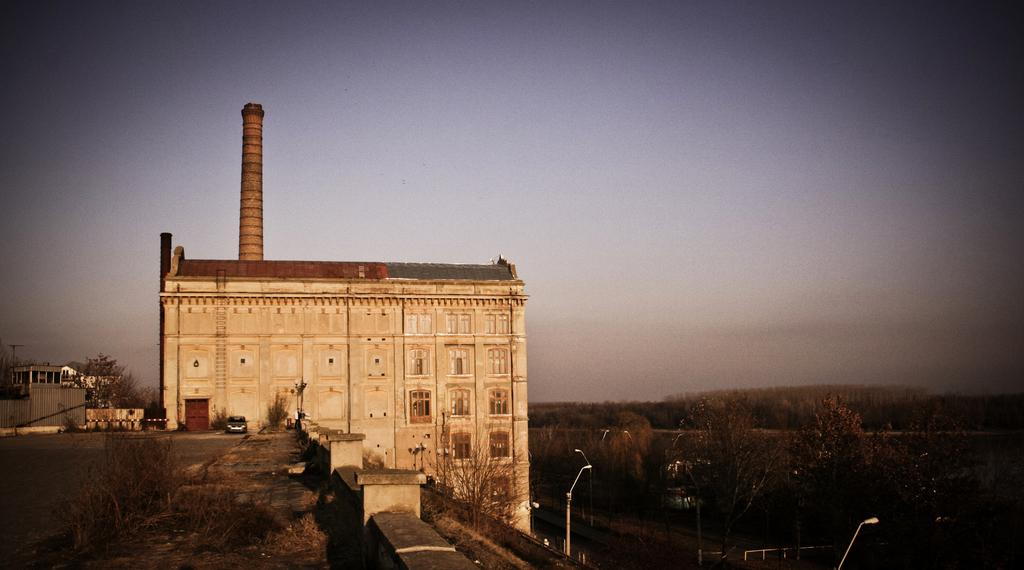What type of structures are visible in the image? There are buildings with windows in the image. What other natural elements can be seen in the image? There are trees in the image. What are the poles used for in the image? The poles are likely used for supporting wires or signs in the image. What mode of transportation is present in the image? There is a car in the image. What type of pathway is visible in the image? There is a road in the image. What can be seen in the background of the image? The sky is visible in the background of the image. What type of advice does the lawyer give to the army in the image? There is no lawyer or army present in the image; it features buildings, trees, poles, a car, a road, and the sky. 